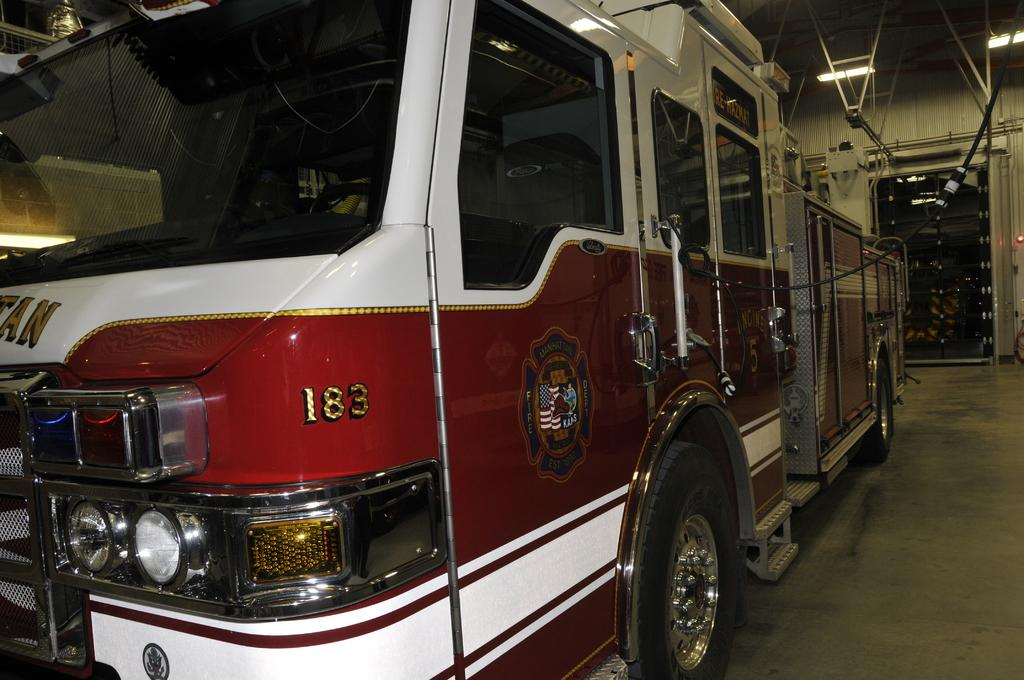What is the main subject in the center of the image? There is a vehicle in the center of the image. What can be seen on the right side of the image? There is a door, a wall, lights, and rods on the right side of the image. What is the surface that the vehicle and other objects are resting on? There is a floor visible at the bottom of the image. What type of crayon is being used to draw on the wall in the image? There is no crayon or drawing present in the image. What musical instrument is being played in the image? There is no musical instrument or indication of music in the image. 